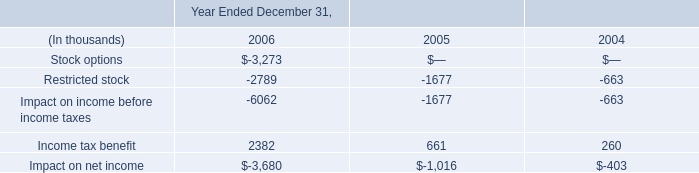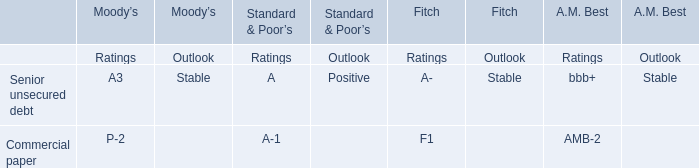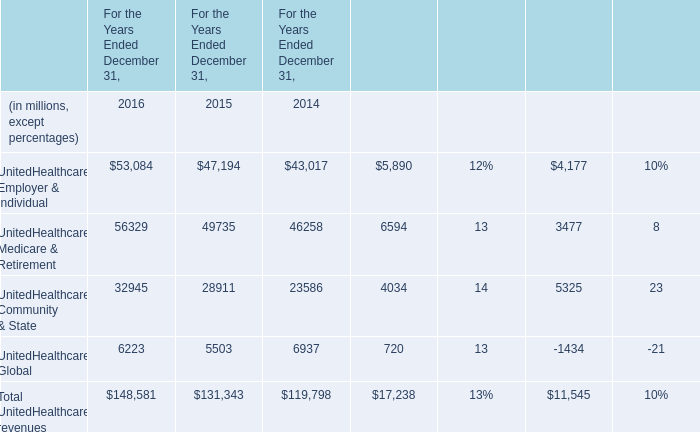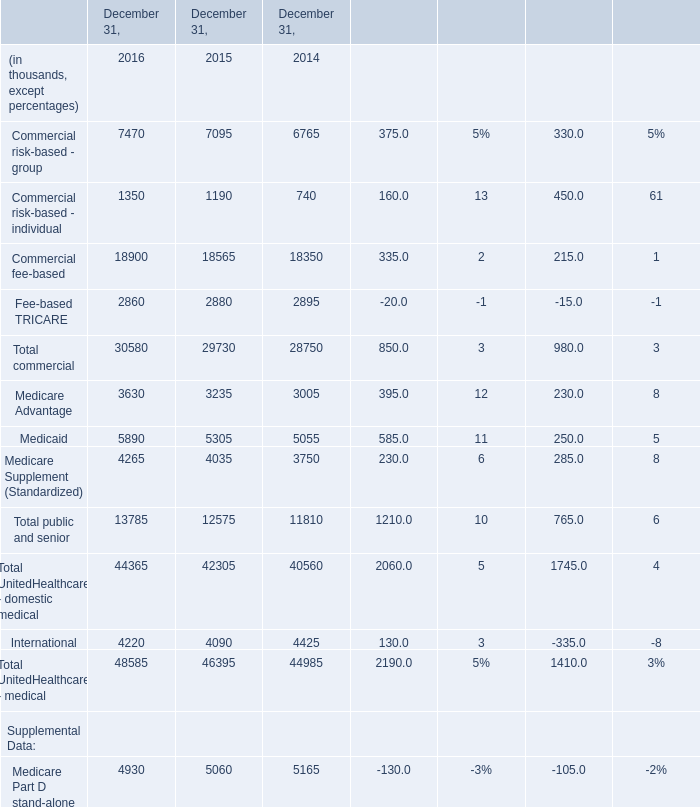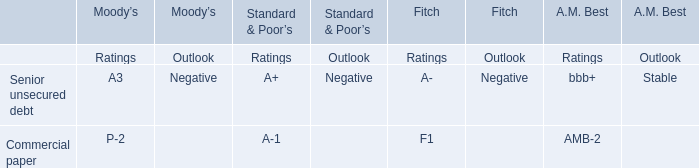What is the total amount of Medicare Advantage of December 31, 2014, and UnitedHealthcare Global of For the Years Ended December 31, 2015 ? 
Computations: (3005.0 + 5503.0)
Answer: 8508.0. 